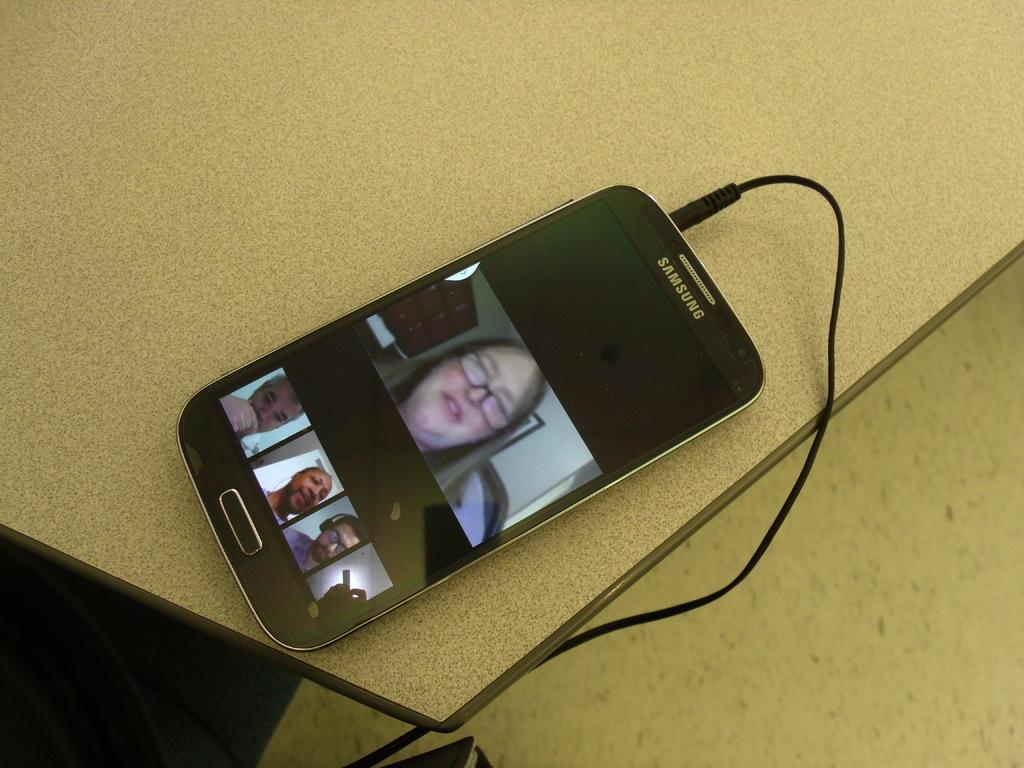<image>
Relay a brief, clear account of the picture shown. A samsung phone plugged into a charger with a womans face. 